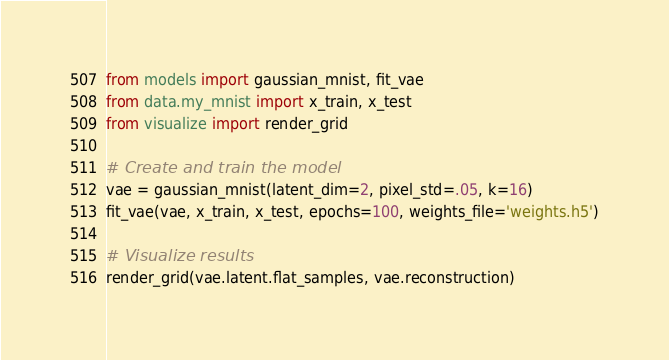Convert code to text. <code><loc_0><loc_0><loc_500><loc_500><_Python_>from models import gaussian_mnist, fit_vae
from data.my_mnist import x_train, x_test
from visualize import render_grid

# Create and train the model
vae = gaussian_mnist(latent_dim=2, pixel_std=.05, k=16)
fit_vae(vae, x_train, x_test, epochs=100, weights_file='weights.h5')

# Visualize results
render_grid(vae.latent.flat_samples, vae.reconstruction)
</code> 